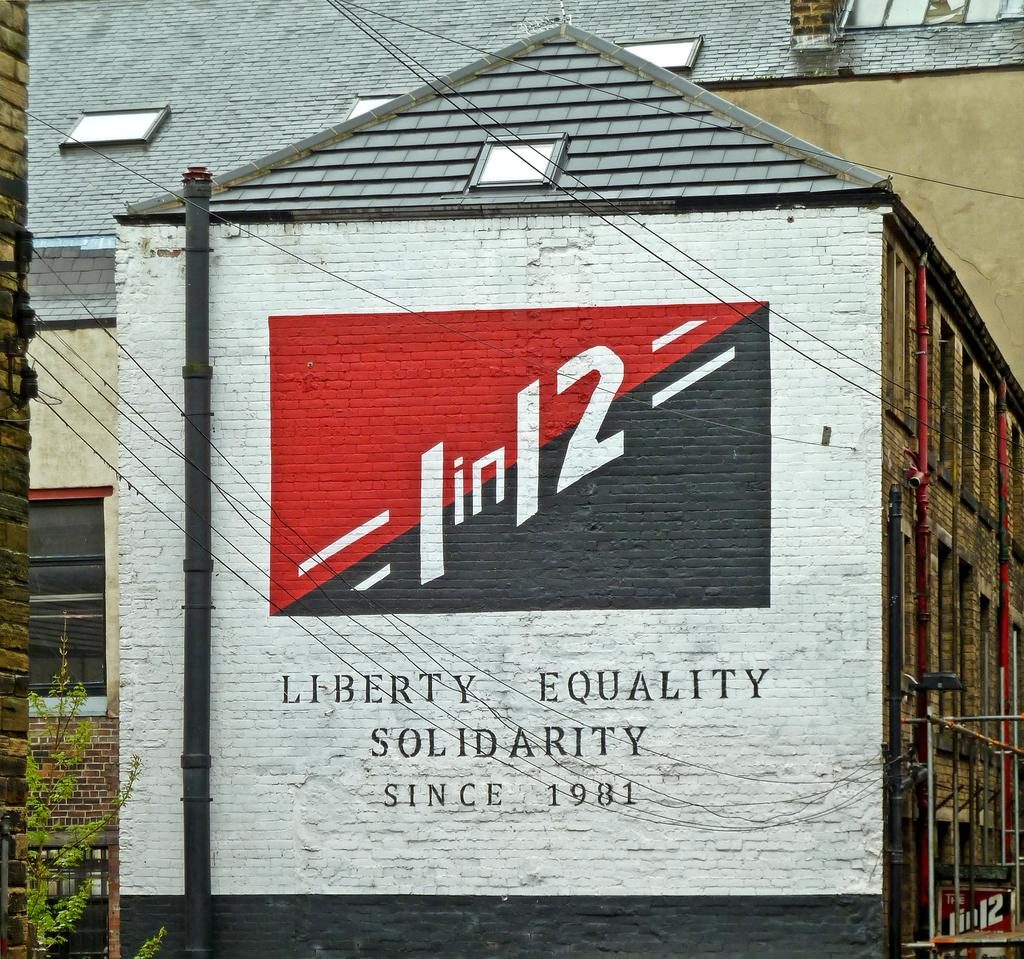What is the main structure visible in the image? There is a building in the image. What can be seen on the building? Something is written on the building, and there is a logo on the building. Are there any natural elements near the building? Yes, there is a tree near the building. What else can be seen in the image? There are wires and other buildings visible in the background. What verse is being recited by the milk in the image? There is no milk present in the image, and therefore no verse being recited. 